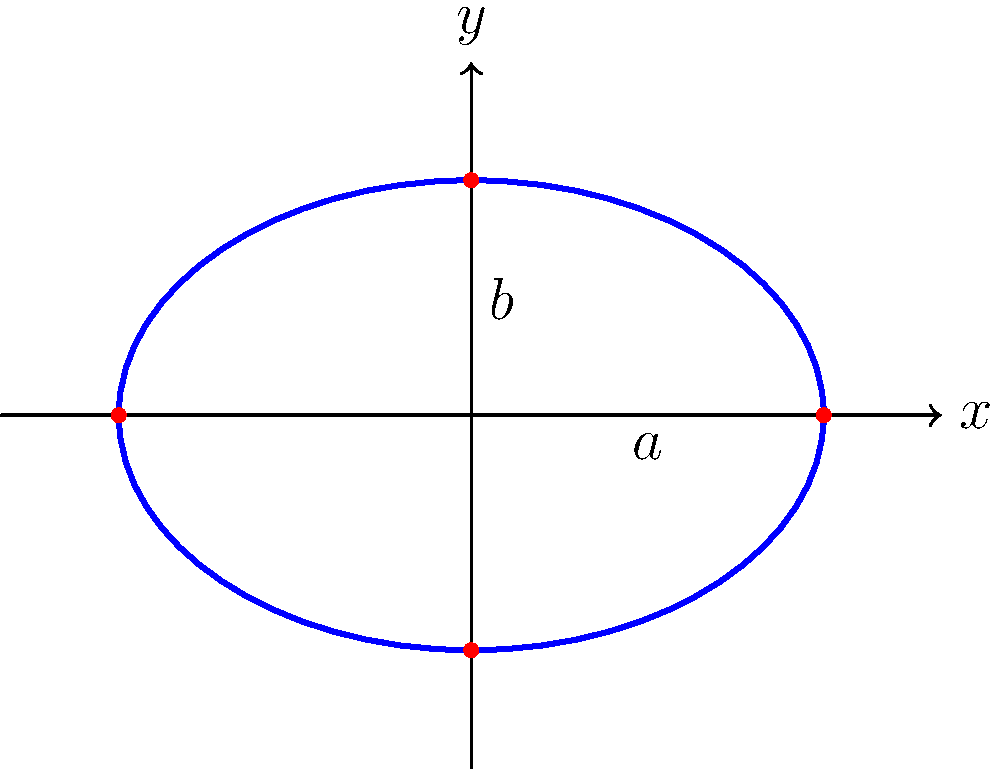In a habitat restoration project, the spread of an invasive species is modeled by the equation $\frac{x^2}{9} + \frac{y^2}{4} = 1$, where $x$ and $y$ represent distances in kilometers from the point of introduction. What is the total area (in square kilometers) affected by this invasive species? To solve this problem, we need to follow these steps:

1) First, recognize that the given equation represents an ellipse. The general form of an ellipse equation is $\frac{x^2}{a^2} + \frac{y^2}{b^2} = 1$, where $a$ and $b$ are the semi-major and semi-minor axes.

2) From the given equation $\frac{x^2}{9} + \frac{y^2}{4} = 1$, we can identify:
   $a^2 = 9$, so $a = 3$ km
   $b^2 = 4$, so $b = 2$ km

3) The area of an ellipse is given by the formula: $A = \pi ab$

4) Substituting the values:
   $A = \pi (3)(2) = 6\pi$ km²

5) Calculate the final value:
   $A = 6\pi \approx 18.85$ km²

Therefore, the total area affected by the invasive species is approximately 18.85 square kilometers.
Answer: $6\pi$ km² (or approximately 18.85 km²) 